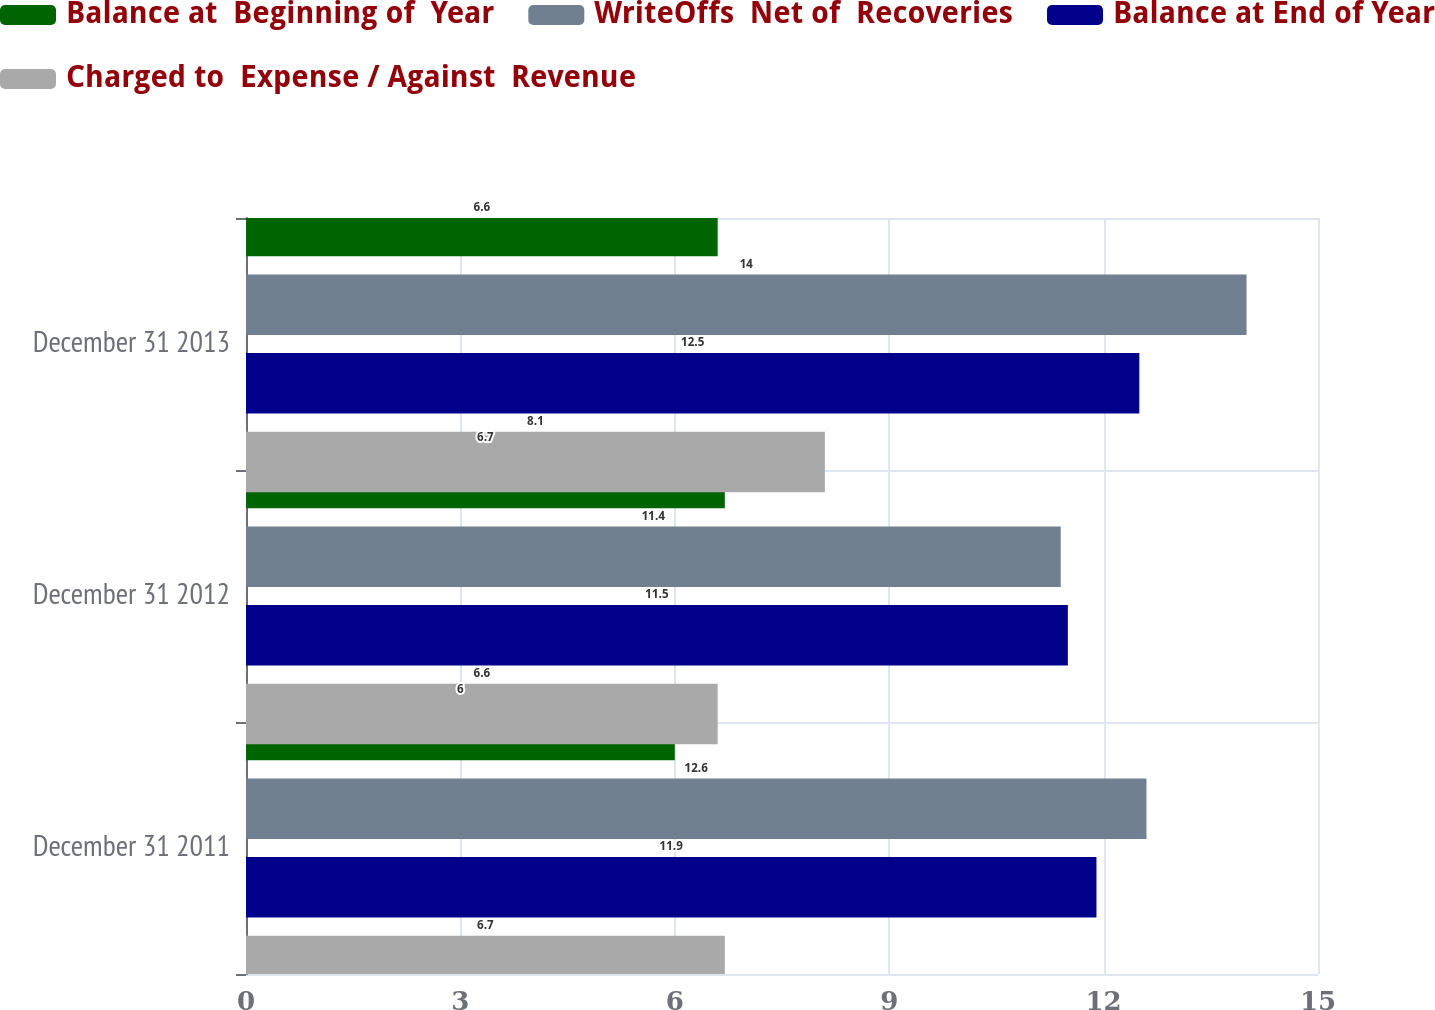<chart> <loc_0><loc_0><loc_500><loc_500><stacked_bar_chart><ecel><fcel>December 31 2011<fcel>December 31 2012<fcel>December 31 2013<nl><fcel>Balance at  Beginning of  Year<fcel>6<fcel>6.7<fcel>6.6<nl><fcel>WriteOffs  Net of  Recoveries<fcel>12.6<fcel>11.4<fcel>14<nl><fcel>Balance at End of Year<fcel>11.9<fcel>11.5<fcel>12.5<nl><fcel>Charged to  Expense / Against  Revenue<fcel>6.7<fcel>6.6<fcel>8.1<nl></chart> 